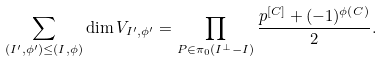<formula> <loc_0><loc_0><loc_500><loc_500>\sum _ { ( I ^ { \prime } , \phi ^ { \prime } ) \leq ( I , \phi ) } \dim V _ { I ^ { \prime } , \phi ^ { \prime } } = \prod _ { P \in \pi _ { 0 } ( I ^ { \perp } - I ) } \frac { p ^ { [ C ] } + ( - 1 ) ^ { \phi ( C ) } } 2 .</formula> 